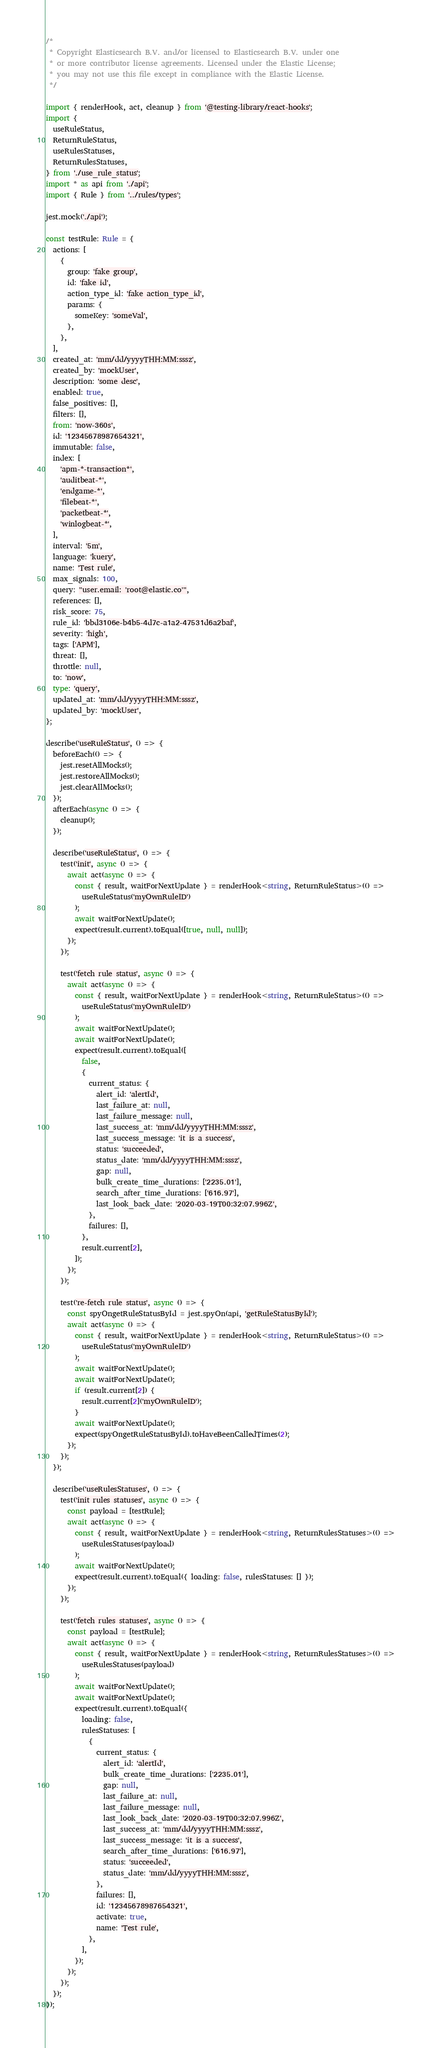<code> <loc_0><loc_0><loc_500><loc_500><_TypeScript_>/*
 * Copyright Elasticsearch B.V. and/or licensed to Elasticsearch B.V. under one
 * or more contributor license agreements. Licensed under the Elastic License;
 * you may not use this file except in compliance with the Elastic License.
 */

import { renderHook, act, cleanup } from '@testing-library/react-hooks';
import {
  useRuleStatus,
  ReturnRuleStatus,
  useRulesStatuses,
  ReturnRulesStatuses,
} from './use_rule_status';
import * as api from './api';
import { Rule } from '../rules/types';

jest.mock('./api');

const testRule: Rule = {
  actions: [
    {
      group: 'fake group',
      id: 'fake id',
      action_type_id: 'fake action_type_id',
      params: {
        someKey: 'someVal',
      },
    },
  ],
  created_at: 'mm/dd/yyyyTHH:MM:sssz',
  created_by: 'mockUser',
  description: 'some desc',
  enabled: true,
  false_positives: [],
  filters: [],
  from: 'now-360s',
  id: '12345678987654321',
  immutable: false,
  index: [
    'apm-*-transaction*',
    'auditbeat-*',
    'endgame-*',
    'filebeat-*',
    'packetbeat-*',
    'winlogbeat-*',
  ],
  interval: '5m',
  language: 'kuery',
  name: 'Test rule',
  max_signals: 100,
  query: "user.email: 'root@elastic.co'",
  references: [],
  risk_score: 75,
  rule_id: 'bbd3106e-b4b5-4d7c-a1a2-47531d6a2baf',
  severity: 'high',
  tags: ['APM'],
  threat: [],
  throttle: null,
  to: 'now',
  type: 'query',
  updated_at: 'mm/dd/yyyyTHH:MM:sssz',
  updated_by: 'mockUser',
};

describe('useRuleStatus', () => {
  beforeEach(() => {
    jest.resetAllMocks();
    jest.restoreAllMocks();
    jest.clearAllMocks();
  });
  afterEach(async () => {
    cleanup();
  });

  describe('useRuleStatus', () => {
    test('init', async () => {
      await act(async () => {
        const { result, waitForNextUpdate } = renderHook<string, ReturnRuleStatus>(() =>
          useRuleStatus('myOwnRuleID')
        );
        await waitForNextUpdate();
        expect(result.current).toEqual([true, null, null]);
      });
    });

    test('fetch rule status', async () => {
      await act(async () => {
        const { result, waitForNextUpdate } = renderHook<string, ReturnRuleStatus>(() =>
          useRuleStatus('myOwnRuleID')
        );
        await waitForNextUpdate();
        await waitForNextUpdate();
        expect(result.current).toEqual([
          false,
          {
            current_status: {
              alert_id: 'alertId',
              last_failure_at: null,
              last_failure_message: null,
              last_success_at: 'mm/dd/yyyyTHH:MM:sssz',
              last_success_message: 'it is a success',
              status: 'succeeded',
              status_date: 'mm/dd/yyyyTHH:MM:sssz',
              gap: null,
              bulk_create_time_durations: ['2235.01'],
              search_after_time_durations: ['616.97'],
              last_look_back_date: '2020-03-19T00:32:07.996Z',
            },
            failures: [],
          },
          result.current[2],
        ]);
      });
    });

    test('re-fetch rule status', async () => {
      const spyOngetRuleStatusById = jest.spyOn(api, 'getRuleStatusById');
      await act(async () => {
        const { result, waitForNextUpdate } = renderHook<string, ReturnRuleStatus>(() =>
          useRuleStatus('myOwnRuleID')
        );
        await waitForNextUpdate();
        await waitForNextUpdate();
        if (result.current[2]) {
          result.current[2]('myOwnRuleID');
        }
        await waitForNextUpdate();
        expect(spyOngetRuleStatusById).toHaveBeenCalledTimes(2);
      });
    });
  });

  describe('useRulesStatuses', () => {
    test('init rules statuses', async () => {
      const payload = [testRule];
      await act(async () => {
        const { result, waitForNextUpdate } = renderHook<string, ReturnRulesStatuses>(() =>
          useRulesStatuses(payload)
        );
        await waitForNextUpdate();
        expect(result.current).toEqual({ loading: false, rulesStatuses: [] });
      });
    });

    test('fetch rules statuses', async () => {
      const payload = [testRule];
      await act(async () => {
        const { result, waitForNextUpdate } = renderHook<string, ReturnRulesStatuses>(() =>
          useRulesStatuses(payload)
        );
        await waitForNextUpdate();
        await waitForNextUpdate();
        expect(result.current).toEqual({
          loading: false,
          rulesStatuses: [
            {
              current_status: {
                alert_id: 'alertId',
                bulk_create_time_durations: ['2235.01'],
                gap: null,
                last_failure_at: null,
                last_failure_message: null,
                last_look_back_date: '2020-03-19T00:32:07.996Z',
                last_success_at: 'mm/dd/yyyyTHH:MM:sssz',
                last_success_message: 'it is a success',
                search_after_time_durations: ['616.97'],
                status: 'succeeded',
                status_date: 'mm/dd/yyyyTHH:MM:sssz',
              },
              failures: [],
              id: '12345678987654321',
              activate: true,
              name: 'Test rule',
            },
          ],
        });
      });
    });
  });
});
</code> 